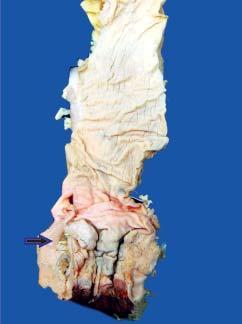does the wedge-shaped infarct show an ulcerated mucosa with thickened wall?
Answer the question using a single word or phrase. No 